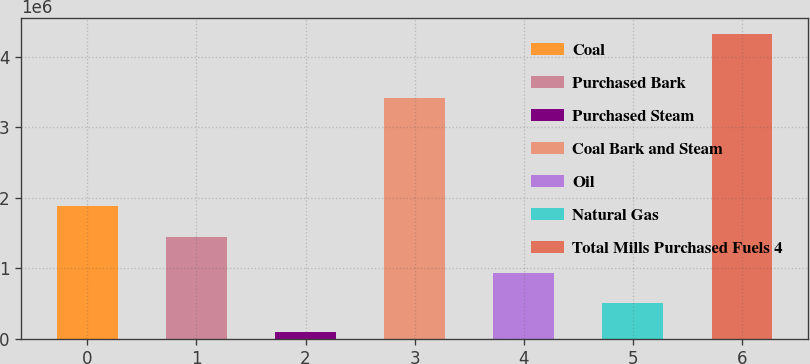<chart> <loc_0><loc_0><loc_500><loc_500><bar_chart><fcel>Coal<fcel>Purchased Bark<fcel>Purchased Steam<fcel>Coal Bark and Steam<fcel>Oil<fcel>Natural Gas<fcel>Total Mills Purchased Fuels 4<nl><fcel>1.87422e+06<fcel>1.44776e+06<fcel>87655<fcel>3.40963e+06<fcel>935176<fcel>511416<fcel>4.32526e+06<nl></chart> 